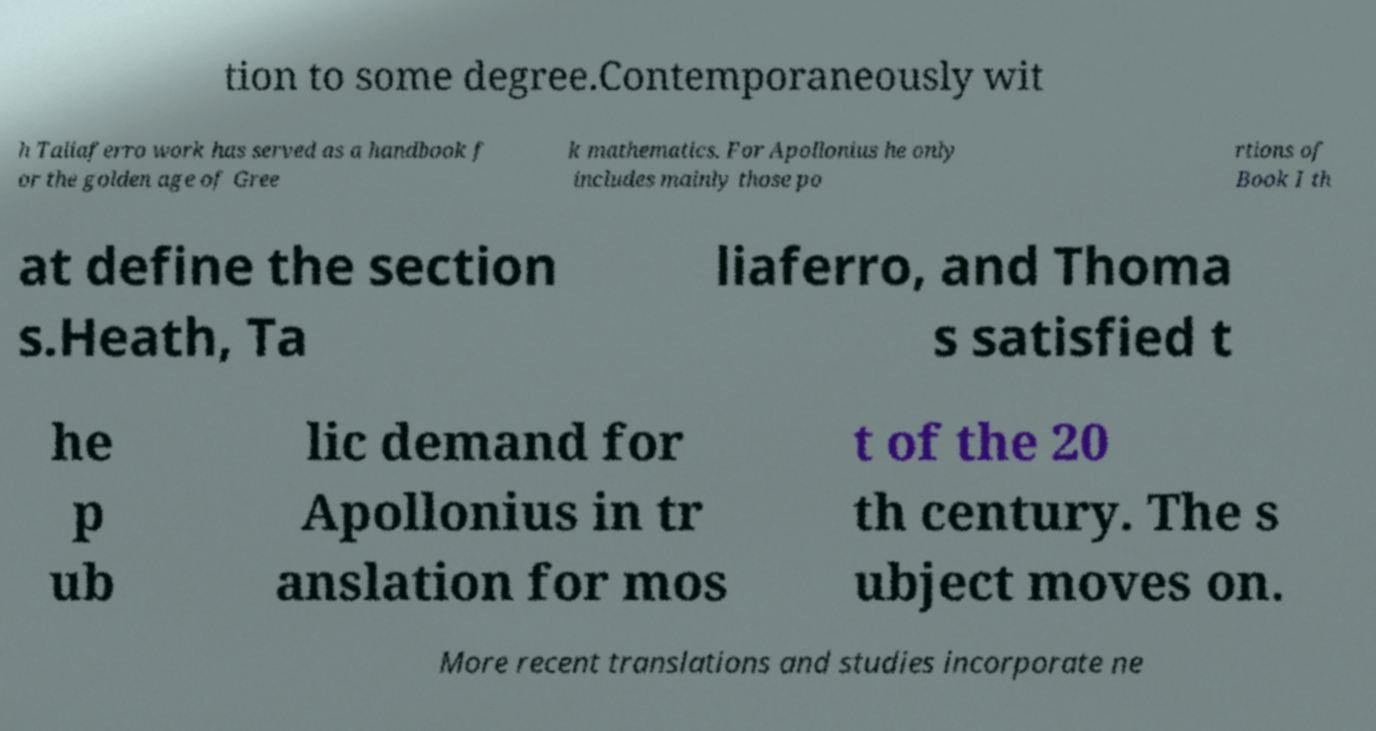What messages or text are displayed in this image? I need them in a readable, typed format. tion to some degree.Contemporaneously wit h Taliaferro work has served as a handbook f or the golden age of Gree k mathematics. For Apollonius he only includes mainly those po rtions of Book I th at define the section s.Heath, Ta liaferro, and Thoma s satisfied t he p ub lic demand for Apollonius in tr anslation for mos t of the 20 th century. The s ubject moves on. More recent translations and studies incorporate ne 